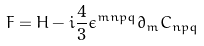<formula> <loc_0><loc_0><loc_500><loc_500>F = H - i \frac { 4 } { 3 } \epsilon ^ { m n p q } \partial _ { m } C _ { n p q }</formula> 